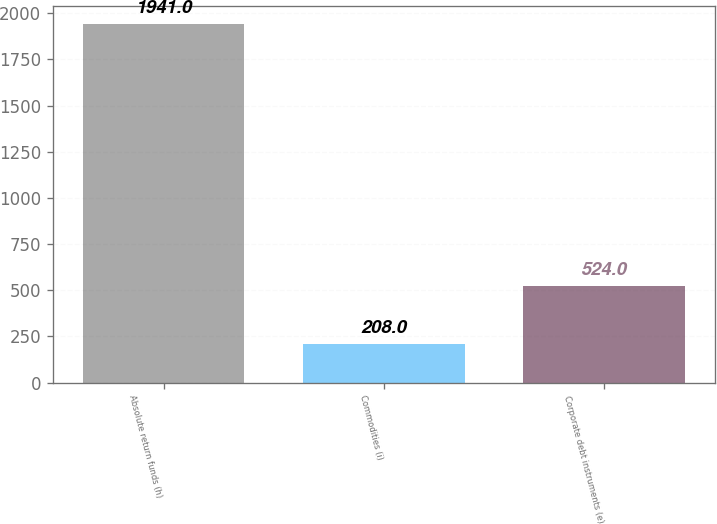Convert chart. <chart><loc_0><loc_0><loc_500><loc_500><bar_chart><fcel>Absolute return funds (h)<fcel>Commodities (i)<fcel>Corporate debt instruments (e)<nl><fcel>1941<fcel>208<fcel>524<nl></chart> 